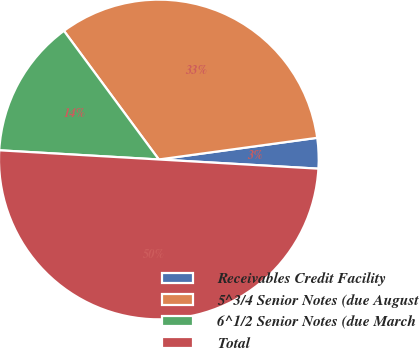Convert chart. <chart><loc_0><loc_0><loc_500><loc_500><pie_chart><fcel>Receivables Credit Facility<fcel>5^3/4 Senior Notes (due August<fcel>6^1/2 Senior Notes (due March<fcel>Total<nl><fcel>3.08%<fcel>32.95%<fcel>13.97%<fcel>50.0%<nl></chart> 